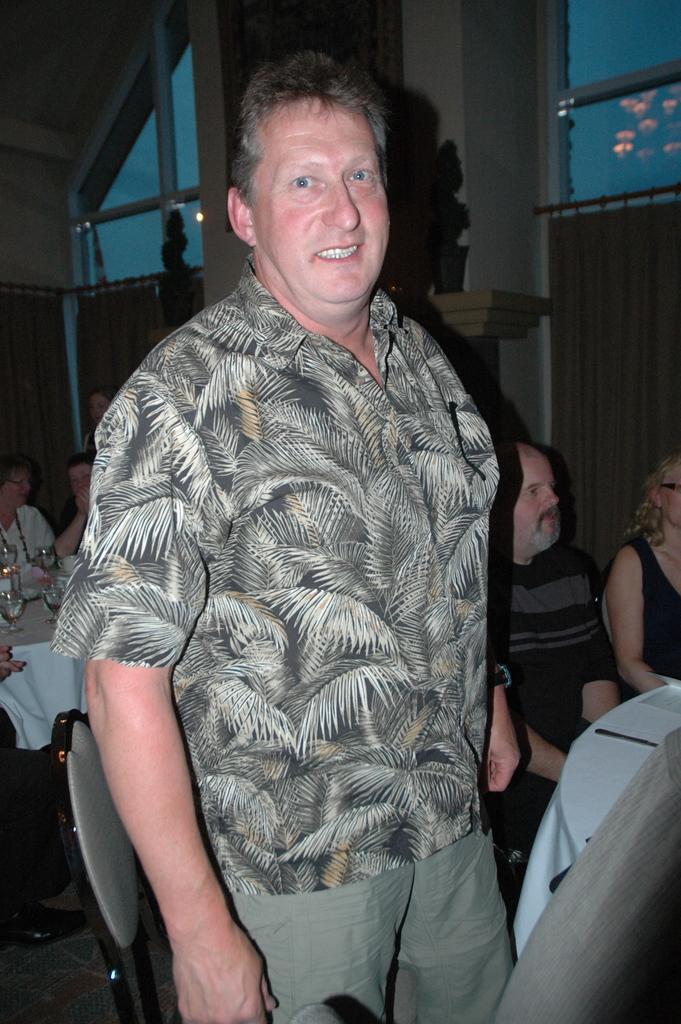Describe this image in one or two sentences. In the center of the image, we can see a person standing and in the background, there are people sitting on the chairs and we can see some glasses, cloths and some other objects on the tables and there is a wall and we can see curtains. 